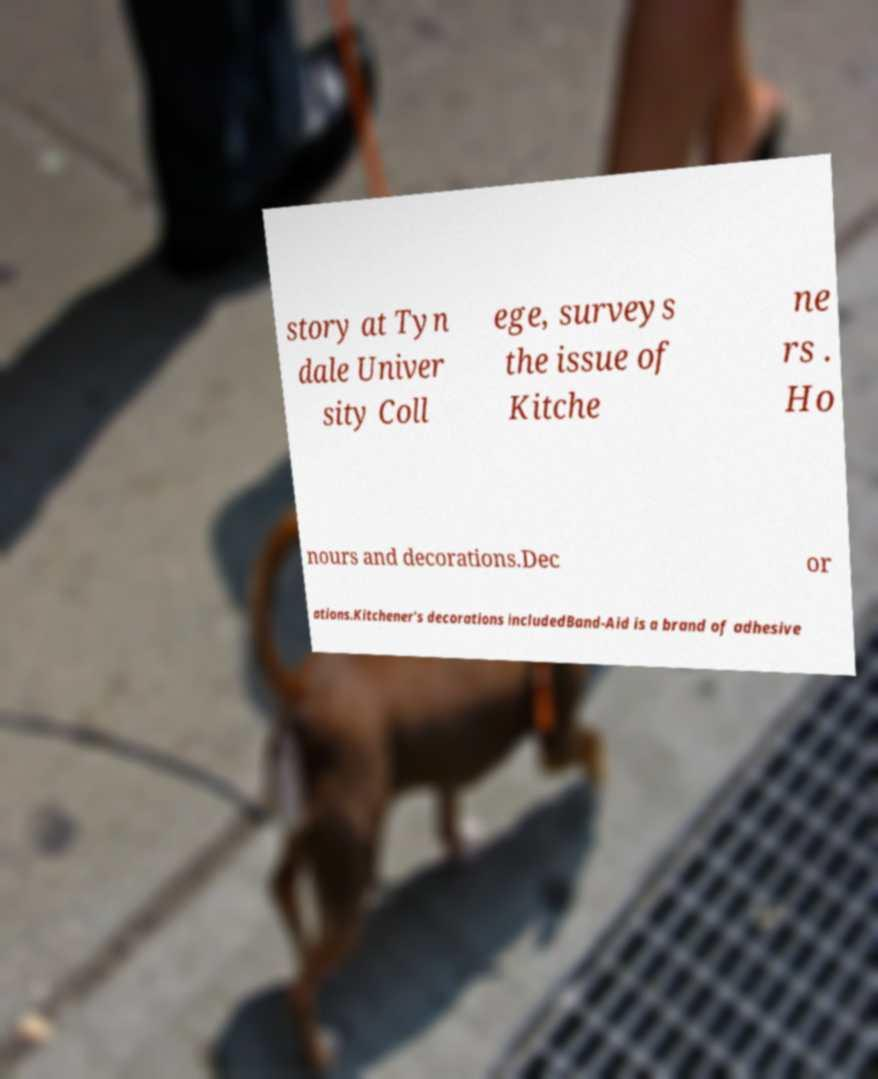Can you accurately transcribe the text from the provided image for me? story at Tyn dale Univer sity Coll ege, surveys the issue of Kitche ne rs . Ho nours and decorations.Dec or ations.Kitchener's decorations includedBand-Aid is a brand of adhesive 